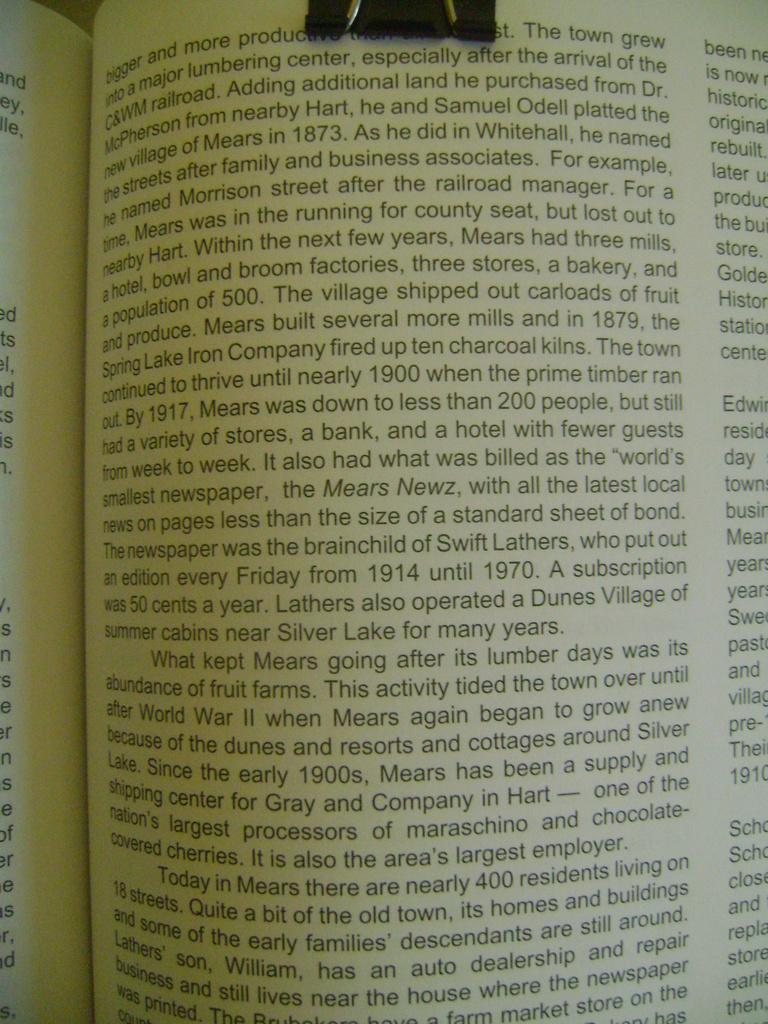<image>
Give a short and clear explanation of the subsequent image. A book is open to a page that starts with the word bigger. 